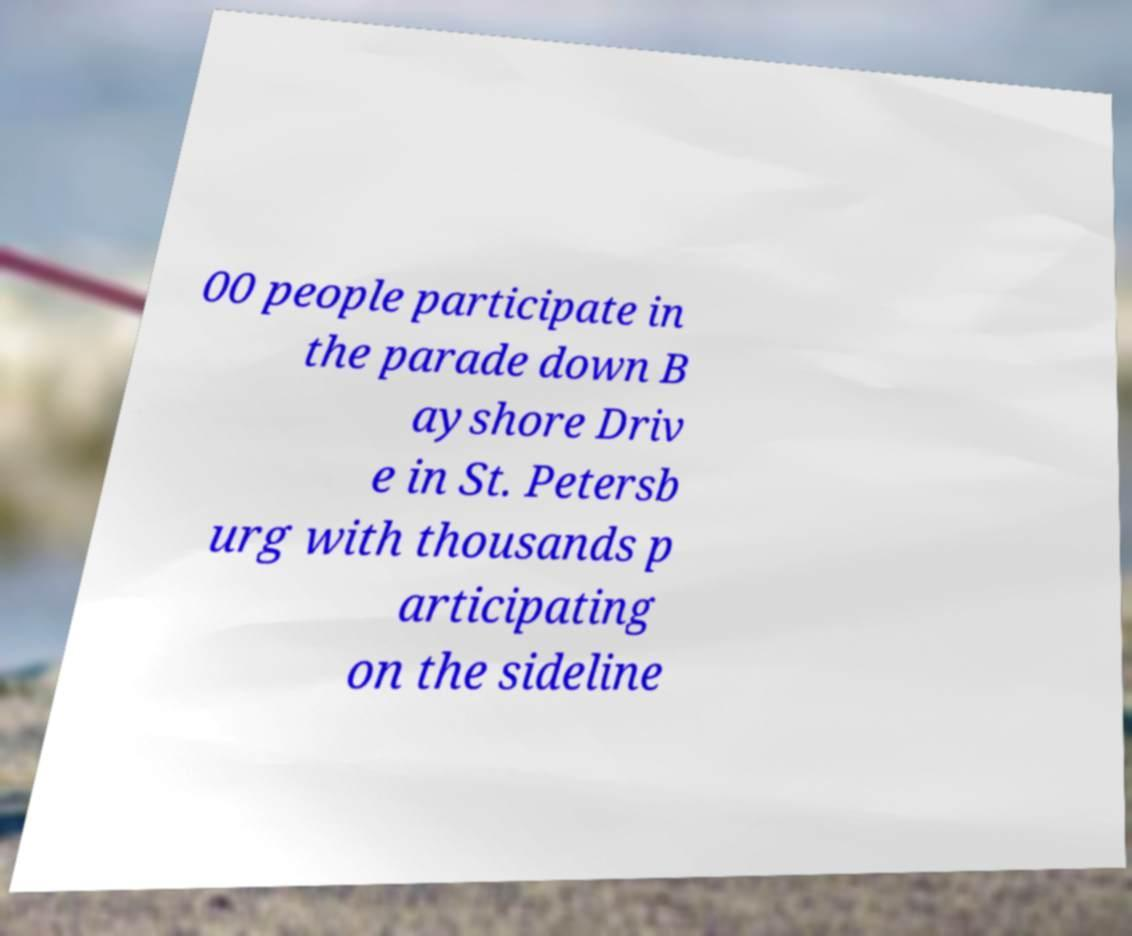There's text embedded in this image that I need extracted. Can you transcribe it verbatim? 00 people participate in the parade down B ayshore Driv e in St. Petersb urg with thousands p articipating on the sideline 